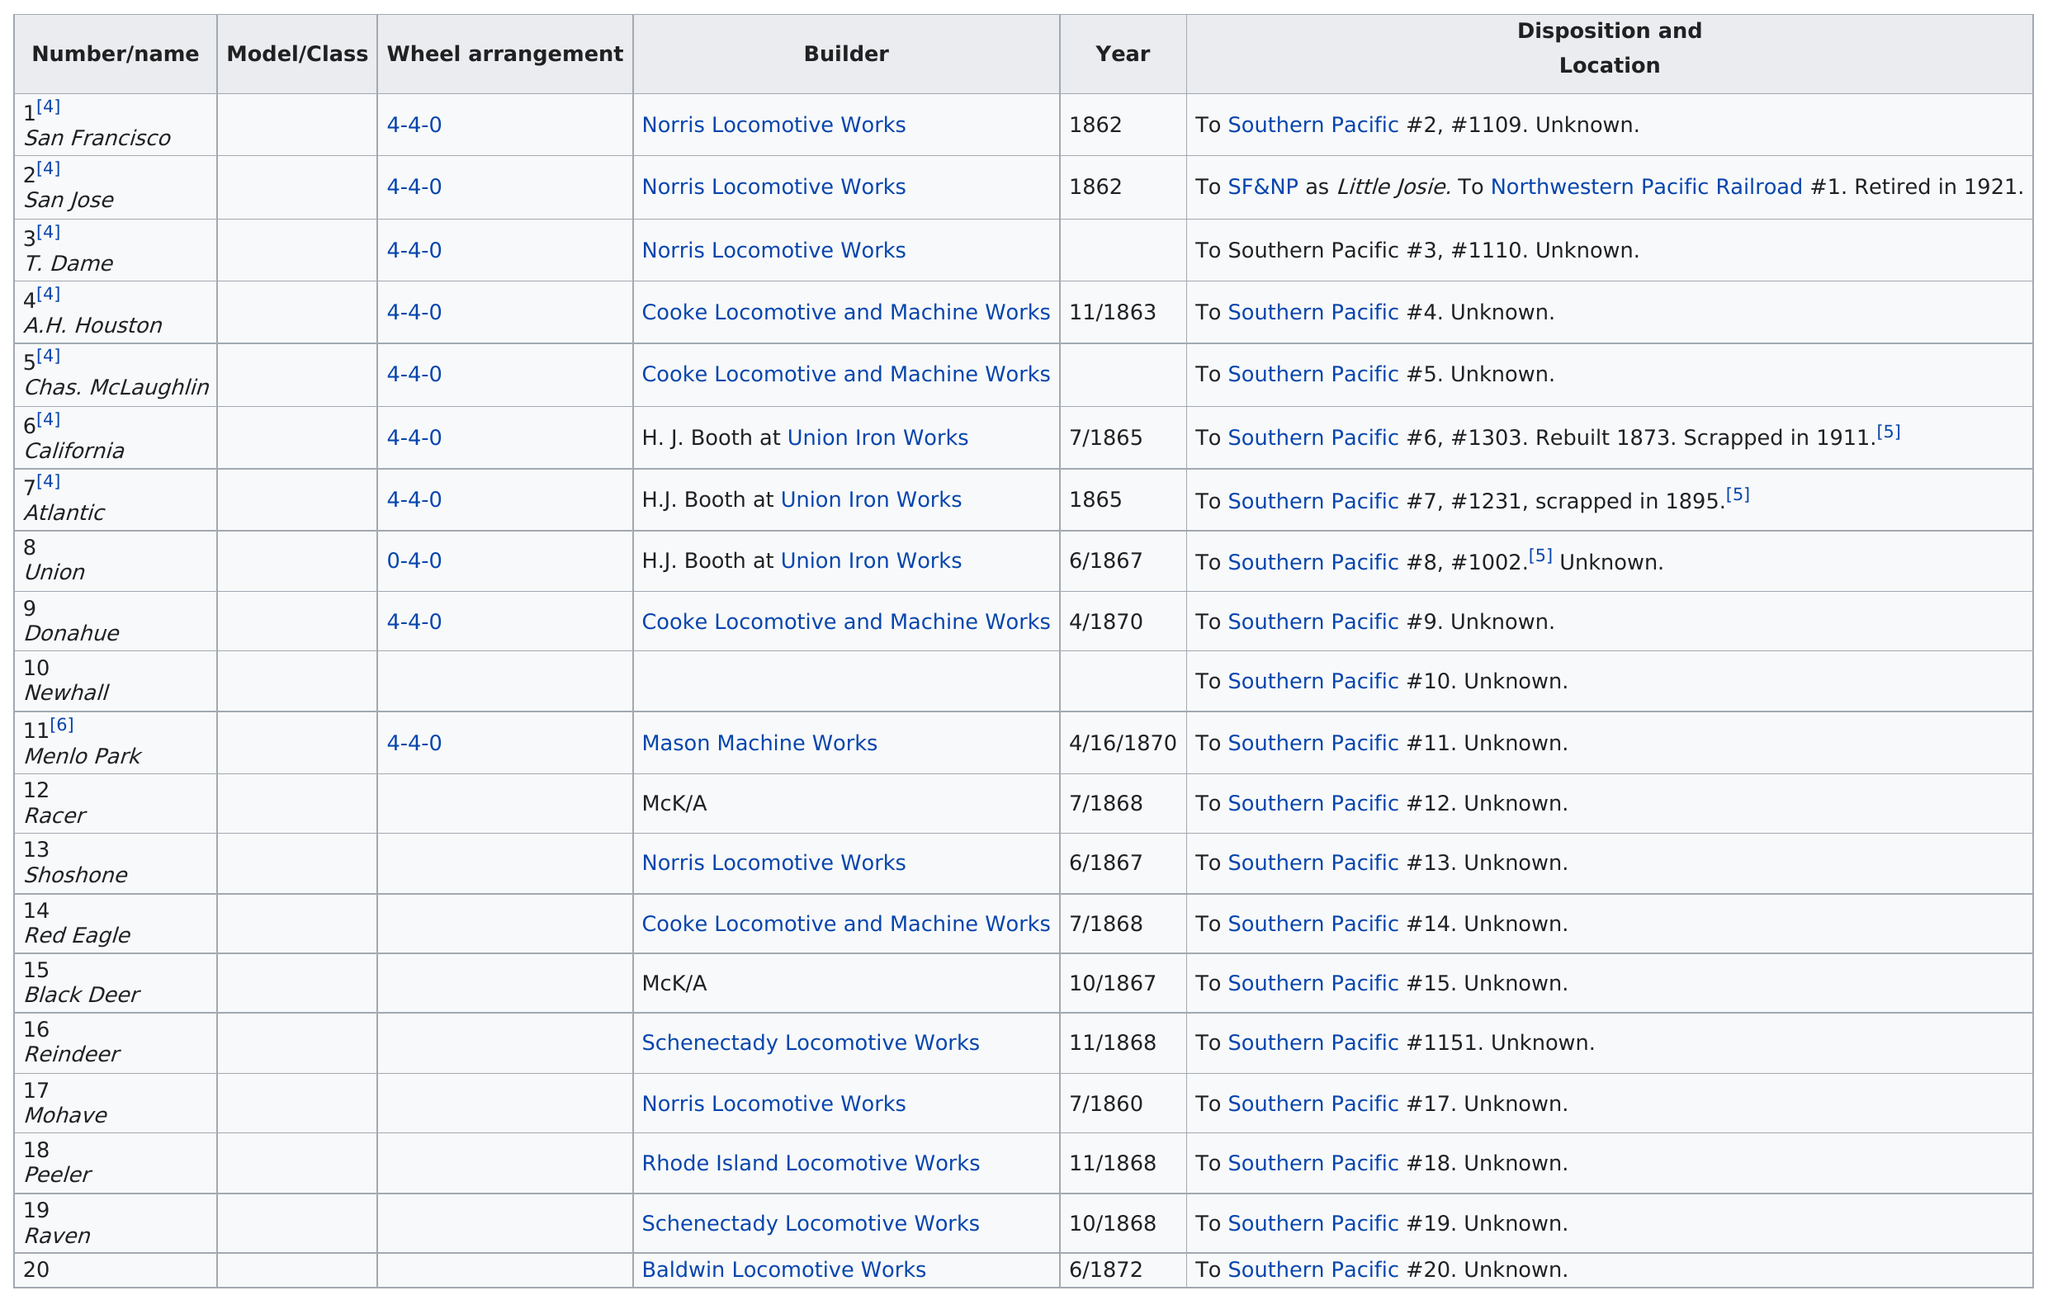Outline some significant characteristics in this image. A total of 19 locomotives have a disposition of being assigned to the Southern Pacific. The raven locomotive has an earlier date than the peeler locomotive. The total number of locomotives provided to Southern Pacific is 19. There are 17 trains with an unknown location. It is known that three of these locomotives shared the same builder as the A.H. Houston. 